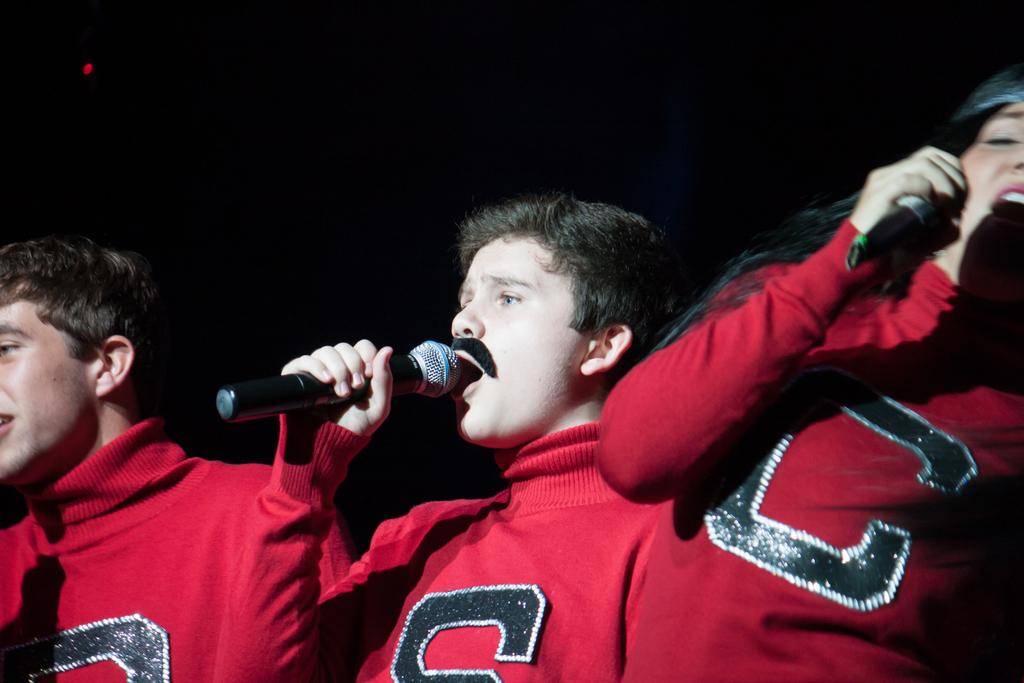How many people are in the image? There are three persons in the image. What are two of the persons on the right side doing? They are holding a mic. What type of temper is displayed by the person on the left side of the image? There is no information about the temper of any person in the image. 